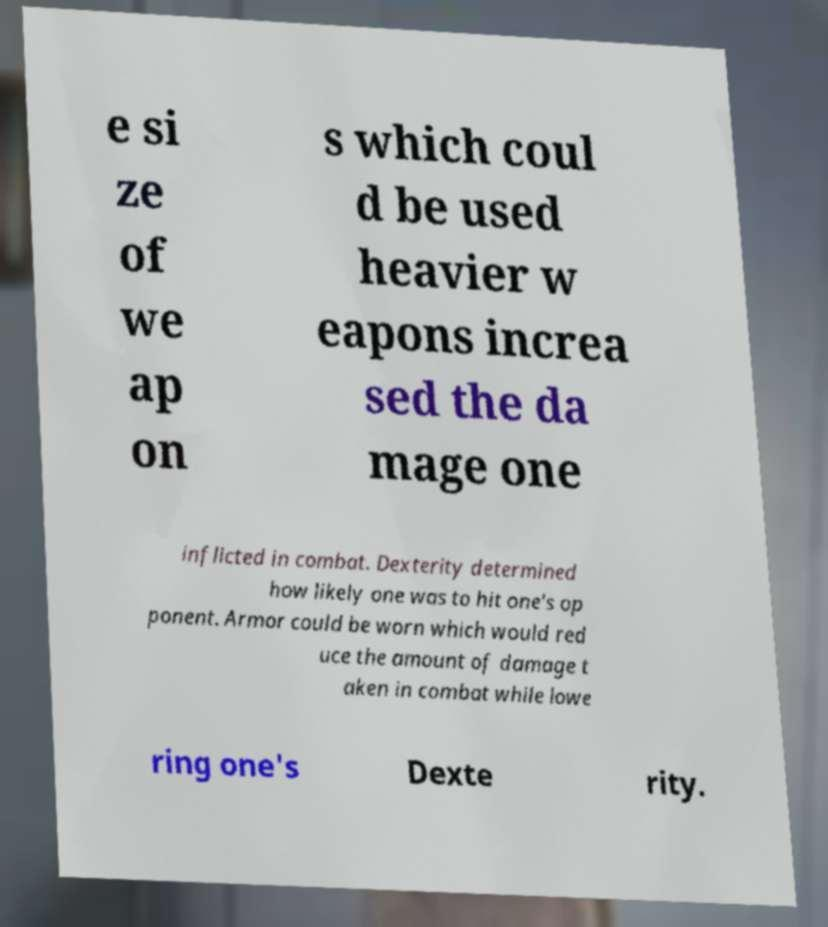Could you assist in decoding the text presented in this image and type it out clearly? e si ze of we ap on s which coul d be used heavier w eapons increa sed the da mage one inflicted in combat. Dexterity determined how likely one was to hit one's op ponent. Armor could be worn which would red uce the amount of damage t aken in combat while lowe ring one's Dexte rity. 